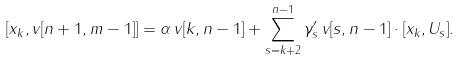Convert formula to latex. <formula><loc_0><loc_0><loc_500><loc_500>[ x _ { k } , v [ n + 1 , m - 1 ] ] = \alpha \, v [ k , n - 1 ] + \sum _ { s = k + 2 } ^ { n - 1 } \gamma _ { s } ^ { \prime } \, v [ s , n - 1 ] \cdot [ x _ { k } , U _ { s } ] .</formula> 